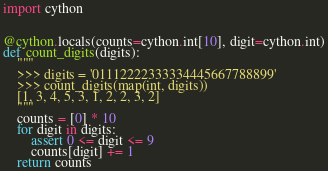Convert code to text. <code><loc_0><loc_0><loc_500><loc_500><_Python_>import cython


@cython.locals(counts=cython.int[10], digit=cython.int)
def count_digits(digits):
    """
    >>> digits = '01112222333334445667788899'
    >>> count_digits(map(int, digits))
    [1, 3, 4, 5, 3, 1, 2, 2, 3, 2]
    """
    counts = [0] * 10
    for digit in digits:
        assert 0 <= digit <= 9
        counts[digit] += 1
    return counts
</code> 